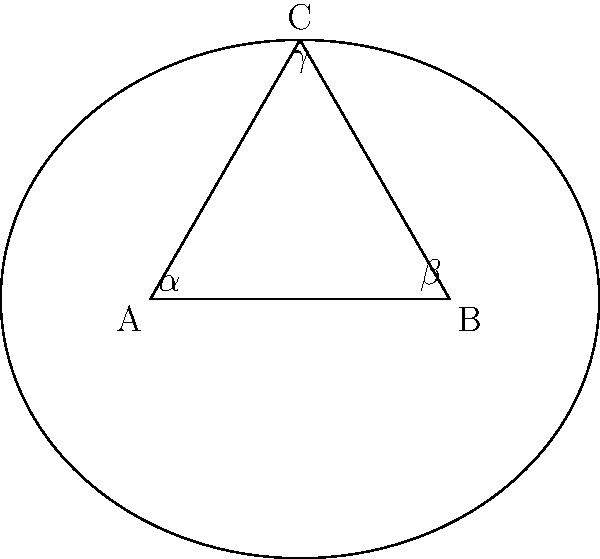In elliptic geometry, a triangle is drawn on the surface of a sphere. If the angles of this triangle are $\alpha$, $\beta$, and $\gamma$, how does their sum compare to the angle sum of a triangle in Euclidean geometry? Explain your reasoning using the concepts of childcare and shape recognition activities for preschoolers. Let's approach this step-by-step, relating it to activities you might use in your home-based daycare:

1) In Euclidean geometry, which we use for flat surfaces like paper or tabletops, the sum of angles in a triangle is always 180°. This is something you might teach preschoolers using shape cutouts or drawings.

2) However, elliptic geometry deals with curved surfaces, like a sphere. Imagine using a beach ball to demonstrate this to the children.

3) On a sphere, the "straight" lines are actually great circles (like the equator). When we draw a triangle using these lines, it creates what's called a spherical triangle.

4) In a spherical triangle, each angle is slightly "pushed out" by the curvature of the surface. This is similar to how a round playground slide curves differently than a flat one.

5) As a result, each angle in a spherical triangle is larger than it would be on a flat surface. You could demonstrate this by drawing on a deflated ball and then inflating it.

6) The sum of the angles in a spherical triangle is always greater than 180°. In fact, it's between 180° and 540°.

7) The exact sum depends on the size of the triangle relative to the sphere. Larger triangles have a larger angle sum. This could be shown using different sized triangles on the same ball.

8) The formula for the angle sum in elliptic geometry is:

   $$\alpha + \beta + \gamma = 180° + A$$

   Where $A$ is the area of the triangle on a unit sphere (radius 1).

9) This excess angle (A) is directly proportional to the area of the triangle, which you could relate to how much space different play areas take up in your daycare.

Therefore, in elliptic geometry, the sum of angles in a triangle is always greater than 180°, unlike in Euclidean geometry where it's exactly 180°.
Answer: Greater than 180° 